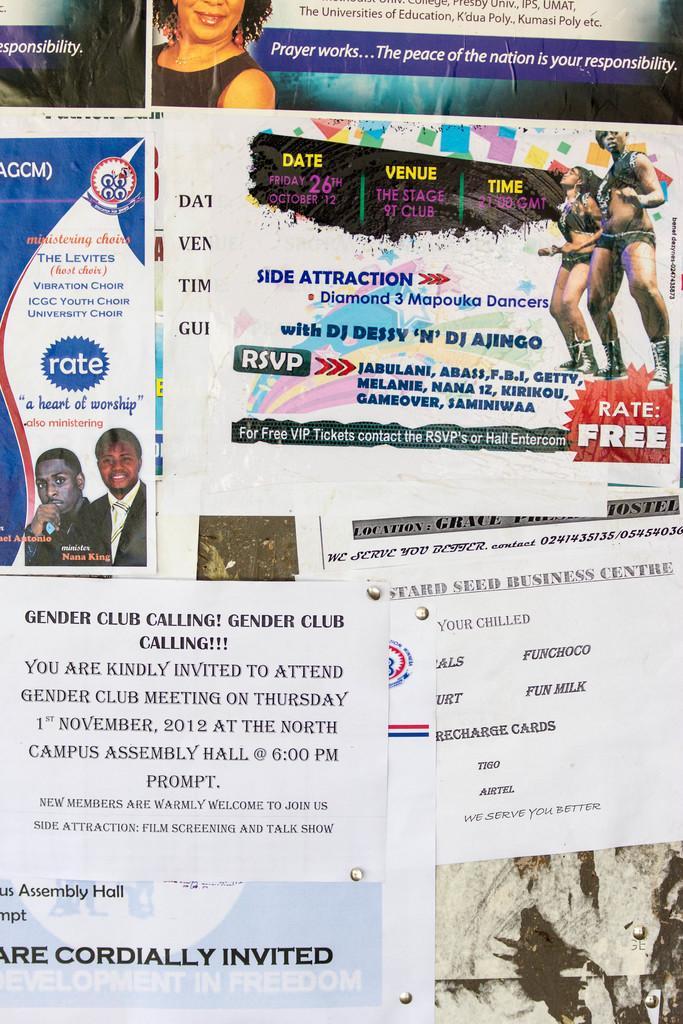Could you give a brief overview of what you see in this image? In this image there are different posters are attached onto this wall. as we can see there are some pictures of a persons on top of this image and there is some text written on that papers. 